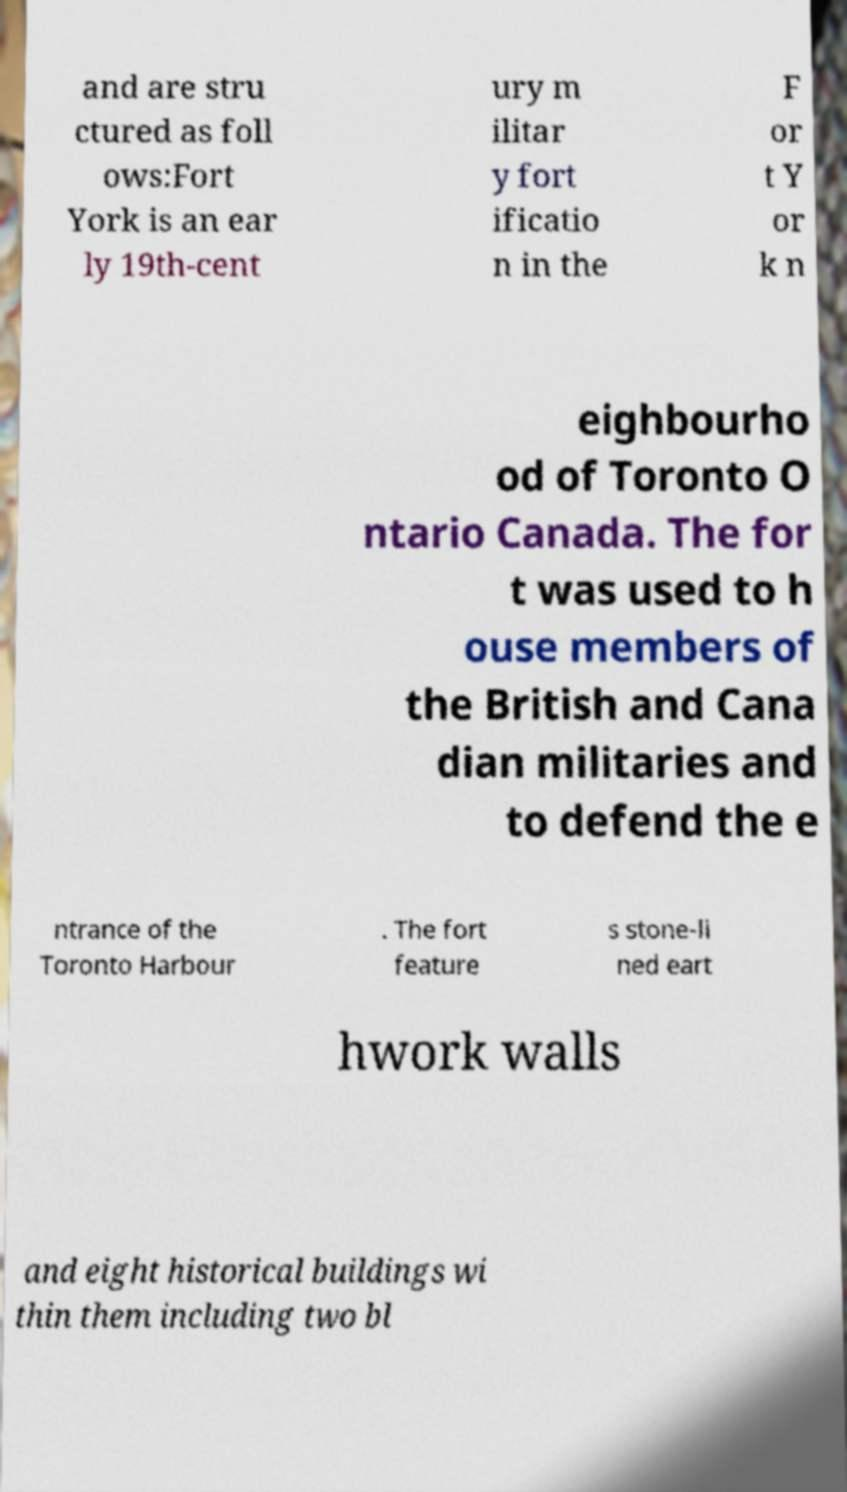Can you accurately transcribe the text from the provided image for me? and are stru ctured as foll ows:Fort York is an ear ly 19th-cent ury m ilitar y fort ificatio n in the F or t Y or k n eighbourho od of Toronto O ntario Canada. The for t was used to h ouse members of the British and Cana dian militaries and to defend the e ntrance of the Toronto Harbour . The fort feature s stone-li ned eart hwork walls and eight historical buildings wi thin them including two bl 